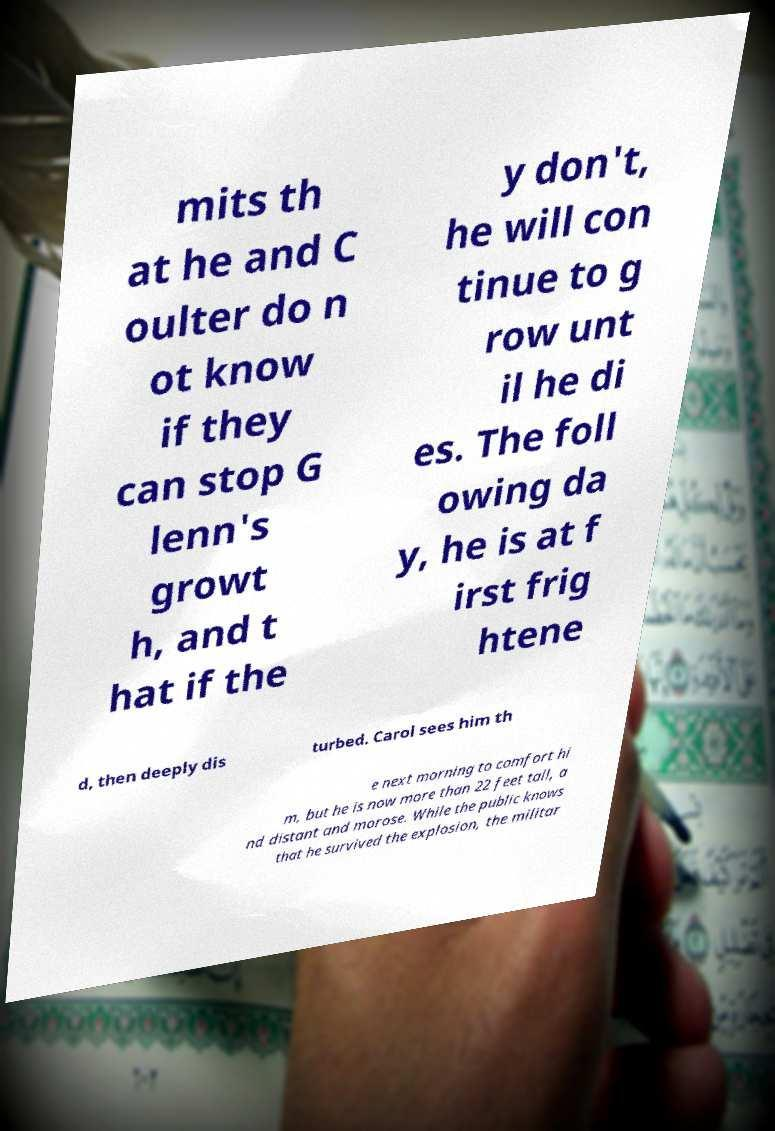There's text embedded in this image that I need extracted. Can you transcribe it verbatim? mits th at he and C oulter do n ot know if they can stop G lenn's growt h, and t hat if the y don't, he will con tinue to g row unt il he di es. The foll owing da y, he is at f irst frig htene d, then deeply dis turbed. Carol sees him th e next morning to comfort hi m, but he is now more than 22 feet tall, a nd distant and morose. While the public knows that he survived the explosion, the militar 